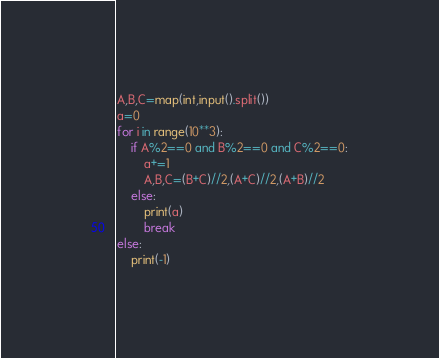Convert code to text. <code><loc_0><loc_0><loc_500><loc_500><_Python_>A,B,C=map(int,input().split())
a=0
for i in range(10**3):
    if A%2==0 and B%2==0 and C%2==0:
        a+=1
        A,B,C=(B+C)//2,(A+C)//2,(A+B)//2
    else:
        print(a)
        break
else:
    print(-1)
</code> 